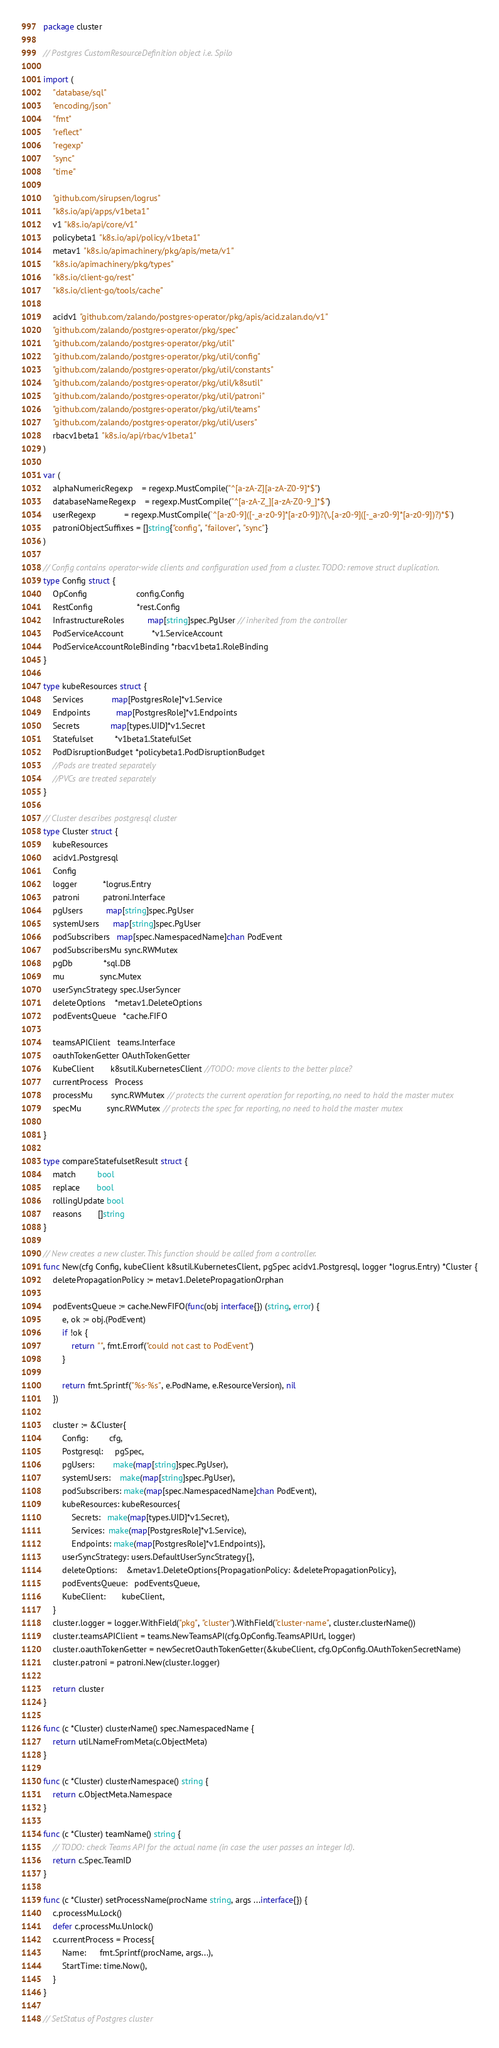Convert code to text. <code><loc_0><loc_0><loc_500><loc_500><_Go_>package cluster

// Postgres CustomResourceDefinition object i.e. Spilo

import (
	"database/sql"
	"encoding/json"
	"fmt"
	"reflect"
	"regexp"
	"sync"
	"time"

	"github.com/sirupsen/logrus"
	"k8s.io/api/apps/v1beta1"
	v1 "k8s.io/api/core/v1"
	policybeta1 "k8s.io/api/policy/v1beta1"
	metav1 "k8s.io/apimachinery/pkg/apis/meta/v1"
	"k8s.io/apimachinery/pkg/types"
	"k8s.io/client-go/rest"
	"k8s.io/client-go/tools/cache"

	acidv1 "github.com/zalando/postgres-operator/pkg/apis/acid.zalan.do/v1"
	"github.com/zalando/postgres-operator/pkg/spec"
	"github.com/zalando/postgres-operator/pkg/util"
	"github.com/zalando/postgres-operator/pkg/util/config"
	"github.com/zalando/postgres-operator/pkg/util/constants"
	"github.com/zalando/postgres-operator/pkg/util/k8sutil"
	"github.com/zalando/postgres-operator/pkg/util/patroni"
	"github.com/zalando/postgres-operator/pkg/util/teams"
	"github.com/zalando/postgres-operator/pkg/util/users"
	rbacv1beta1 "k8s.io/api/rbac/v1beta1"
)

var (
	alphaNumericRegexp    = regexp.MustCompile("^[a-zA-Z][a-zA-Z0-9]*$")
	databaseNameRegexp    = regexp.MustCompile("^[a-zA-Z_][a-zA-Z0-9_]*$")
	userRegexp            = regexp.MustCompile(`^[a-z0-9]([-_a-z0-9]*[a-z0-9])?(\.[a-z0-9]([-_a-z0-9]*[a-z0-9])?)*$`)
	patroniObjectSuffixes = []string{"config", "failover", "sync"}
)

// Config contains operator-wide clients and configuration used from a cluster. TODO: remove struct duplication.
type Config struct {
	OpConfig                     config.Config
	RestConfig                   *rest.Config
	InfrastructureRoles          map[string]spec.PgUser // inherited from the controller
	PodServiceAccount            *v1.ServiceAccount
	PodServiceAccountRoleBinding *rbacv1beta1.RoleBinding
}

type kubeResources struct {
	Services            map[PostgresRole]*v1.Service
	Endpoints           map[PostgresRole]*v1.Endpoints
	Secrets             map[types.UID]*v1.Secret
	Statefulset         *v1beta1.StatefulSet
	PodDisruptionBudget *policybeta1.PodDisruptionBudget
	//Pods are treated separately
	//PVCs are treated separately
}

// Cluster describes postgresql cluster
type Cluster struct {
	kubeResources
	acidv1.Postgresql
	Config
	logger           *logrus.Entry
	patroni          patroni.Interface
	pgUsers          map[string]spec.PgUser
	systemUsers      map[string]spec.PgUser
	podSubscribers   map[spec.NamespacedName]chan PodEvent
	podSubscribersMu sync.RWMutex
	pgDb             *sql.DB
	mu               sync.Mutex
	userSyncStrategy spec.UserSyncer
	deleteOptions    *metav1.DeleteOptions
	podEventsQueue   *cache.FIFO

	teamsAPIClient   teams.Interface
	oauthTokenGetter OAuthTokenGetter
	KubeClient       k8sutil.KubernetesClient //TODO: move clients to the better place?
	currentProcess   Process
	processMu        sync.RWMutex // protects the current operation for reporting, no need to hold the master mutex
	specMu           sync.RWMutex // protects the spec for reporting, no need to hold the master mutex

}

type compareStatefulsetResult struct {
	match         bool
	replace       bool
	rollingUpdate bool
	reasons       []string
}

// New creates a new cluster. This function should be called from a controller.
func New(cfg Config, kubeClient k8sutil.KubernetesClient, pgSpec acidv1.Postgresql, logger *logrus.Entry) *Cluster {
	deletePropagationPolicy := metav1.DeletePropagationOrphan

	podEventsQueue := cache.NewFIFO(func(obj interface{}) (string, error) {
		e, ok := obj.(PodEvent)
		if !ok {
			return "", fmt.Errorf("could not cast to PodEvent")
		}

		return fmt.Sprintf("%s-%s", e.PodName, e.ResourceVersion), nil
	})

	cluster := &Cluster{
		Config:         cfg,
		Postgresql:     pgSpec,
		pgUsers:        make(map[string]spec.PgUser),
		systemUsers:    make(map[string]spec.PgUser),
		podSubscribers: make(map[spec.NamespacedName]chan PodEvent),
		kubeResources: kubeResources{
			Secrets:   make(map[types.UID]*v1.Secret),
			Services:  make(map[PostgresRole]*v1.Service),
			Endpoints: make(map[PostgresRole]*v1.Endpoints)},
		userSyncStrategy: users.DefaultUserSyncStrategy{},
		deleteOptions:    &metav1.DeleteOptions{PropagationPolicy: &deletePropagationPolicy},
		podEventsQueue:   podEventsQueue,
		KubeClient:       kubeClient,
	}
	cluster.logger = logger.WithField("pkg", "cluster").WithField("cluster-name", cluster.clusterName())
	cluster.teamsAPIClient = teams.NewTeamsAPI(cfg.OpConfig.TeamsAPIUrl, logger)
	cluster.oauthTokenGetter = newSecretOauthTokenGetter(&kubeClient, cfg.OpConfig.OAuthTokenSecretName)
	cluster.patroni = patroni.New(cluster.logger)

	return cluster
}

func (c *Cluster) clusterName() spec.NamespacedName {
	return util.NameFromMeta(c.ObjectMeta)
}

func (c *Cluster) clusterNamespace() string {
	return c.ObjectMeta.Namespace
}

func (c *Cluster) teamName() string {
	// TODO: check Teams API for the actual name (in case the user passes an integer Id).
	return c.Spec.TeamID
}

func (c *Cluster) setProcessName(procName string, args ...interface{}) {
	c.processMu.Lock()
	defer c.processMu.Unlock()
	c.currentProcess = Process{
		Name:      fmt.Sprintf(procName, args...),
		StartTime: time.Now(),
	}
}

// SetStatus of Postgres cluster</code> 